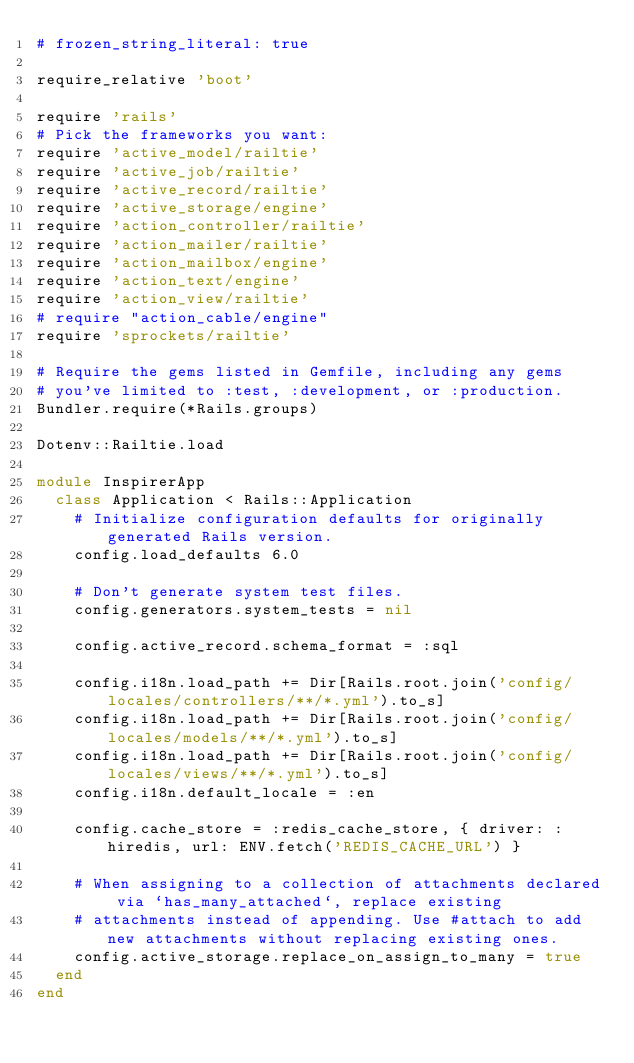Convert code to text. <code><loc_0><loc_0><loc_500><loc_500><_Ruby_># frozen_string_literal: true

require_relative 'boot'

require 'rails'
# Pick the frameworks you want:
require 'active_model/railtie'
require 'active_job/railtie'
require 'active_record/railtie'
require 'active_storage/engine'
require 'action_controller/railtie'
require 'action_mailer/railtie'
require 'action_mailbox/engine'
require 'action_text/engine'
require 'action_view/railtie'
# require "action_cable/engine"
require 'sprockets/railtie'

# Require the gems listed in Gemfile, including any gems
# you've limited to :test, :development, or :production.
Bundler.require(*Rails.groups)

Dotenv::Railtie.load

module InspirerApp
  class Application < Rails::Application
    # Initialize configuration defaults for originally generated Rails version.
    config.load_defaults 6.0

    # Don't generate system test files.
    config.generators.system_tests = nil

    config.active_record.schema_format = :sql

    config.i18n.load_path += Dir[Rails.root.join('config/locales/controllers/**/*.yml').to_s]
    config.i18n.load_path += Dir[Rails.root.join('config/locales/models/**/*.yml').to_s]
    config.i18n.load_path += Dir[Rails.root.join('config/locales/views/**/*.yml').to_s]
    config.i18n.default_locale = :en

    config.cache_store = :redis_cache_store, { driver: :hiredis, url: ENV.fetch('REDIS_CACHE_URL') }

    # When assigning to a collection of attachments declared via `has_many_attached`, replace existing
    # attachments instead of appending. Use #attach to add new attachments without replacing existing ones.
    config.active_storage.replace_on_assign_to_many = true
  end
end
</code> 